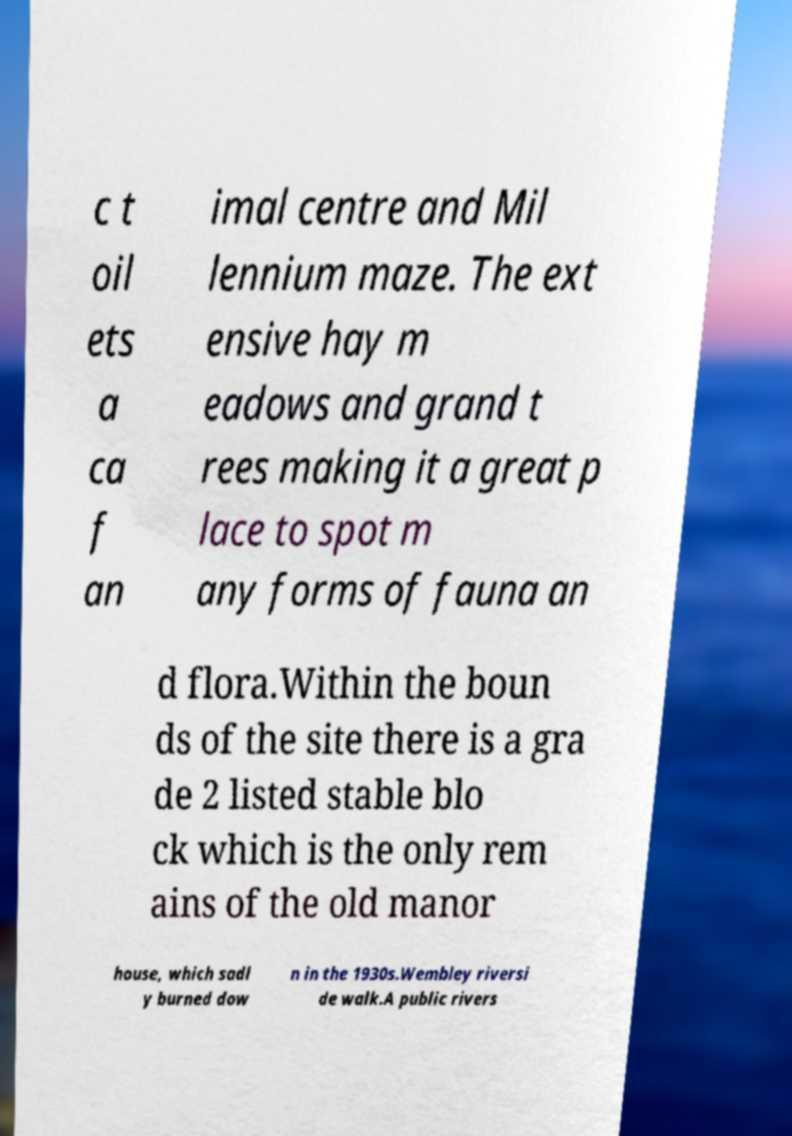Could you extract and type out the text from this image? c t oil ets a ca f an imal centre and Mil lennium maze. The ext ensive hay m eadows and grand t rees making it a great p lace to spot m any forms of fauna an d flora.Within the boun ds of the site there is a gra de 2 listed stable blo ck which is the only rem ains of the old manor house, which sadl y burned dow n in the 1930s.Wembley riversi de walk.A public rivers 